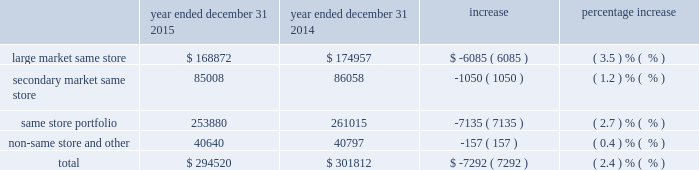The increase in property operating expenses from our large market same store group is primarily the result of increases in real estate taxes of $ 3.2 million , personnel expenses of $ 1.9 million , water expenses of approximately $ 1.0 million , cable expenses of $ 0.5 million , and waste removal expenses of $ 0.2 million .
The increase in property operating expenses from our secondary market same store group is primarily a result of increases in other operating expenses of $ 1.5 million , real estate taxes of $ 1.1 million , and personnel expenses of $ 1.2 million .
The decrease in property operating expenses from our non-same store and other group is primarily the result of decreases in personnel expenses of $ 2.4 million and utility expenses of $ 1.7 million .
Depreciation and amortization the table shows our depreciation and amortization expense by segment for the years ended december 31 , 2015 and december 31 , 2014 ( dollars in thousands ) : year ended december 31 , 2015 year ended december 31 , 2014 increase percentage increase .
The decrease in depreciation and amortization expense is primarily due to a decrease of $ 19.4 million related to the amortization of the fair value of in-place leases and resident relationships acquired as a result of the merger from the year ended december 31 , 2014 to the year ended december 31 , 2015 .
This decrease was partially offset by an increase in depreciation expense of $ 11.7 million driven by an increase in gross real estate assets from the year ended december 31 , 2014 to the year ended december 31 , 2015 .
Property management expenses property management expenses for the year ended december 31 , 2015 were approximately $ 31.0 million , a decrease of $ 1.1 million from the year ended december 31 , 2014 .
The majority of the decrease was related to a decrease in state franchise taxes of $ 2.1 million , partially offset by an increase in insurance expense of $ 0.6 million , an increase in payroll expense of $ 0.3 million , and an increase in incentive expense $ 0.3 million .
General and administrative expenses general and administrative expenses for the year ended december 31 , 2015 were approximately $ 25.7 million , an increase of $ 4.8 million from the year ended december 31 , 2014 .
The majority of the increase was related to increases in legal fees of $ 2.7 million and stock option expenses of $ 1.6 million .
Merger and integration related expenses there were no merger or integration related expenses for the year ended december 31 , 2015 , as these expenses related primarily to severance , legal , professional , temporary systems , staffing , and facilities costs incurred for the acquisition and integration of colonial .
For the year ended december 31 , 2014 , merger and integration related expenses were approximately $ 3.2 million and $ 8.4 million , respectively .
Interest expense interest expense for the year ended december 31 , 2015 was approximately $ 122.3 million , a decrease of $ 1.6 million from the year ended december 31 , 2014 .
The decrease was primarily the result of a decrease in amortization of deferred financing cost from the year ended december 31 , 2014 to the year ended december 31 , 2015 of approximately $ 0.9 million .
Also , the overall debt balance decreased from $ 3.5 billion to $ 3.4 billion , a decrease of $ 85.1 million .
The average effective interest rate remained at 3.7% ( 3.7 % ) and the average years to rate maturity increased from 4.4 years to 4.8 years .
Job title mid-america apartment 10-k revision 1 serial <12345678> date sunday , march 20 , 2016 job number 304352-1 type page no .
50 operator abigaels .
What is the variation observed in the percentual decrease of the large market same-store and the secondary market same-store during 2014 and 2015? 
Rationale: it is the difference between those percentages .
Computations: (3.5 - 1.2)
Answer: 2.3. The increase in property operating expenses from our large market same store group is primarily the result of increases in real estate taxes of $ 3.2 million , personnel expenses of $ 1.9 million , water expenses of approximately $ 1.0 million , cable expenses of $ 0.5 million , and waste removal expenses of $ 0.2 million .
The increase in property operating expenses from our secondary market same store group is primarily a result of increases in other operating expenses of $ 1.5 million , real estate taxes of $ 1.1 million , and personnel expenses of $ 1.2 million .
The decrease in property operating expenses from our non-same store and other group is primarily the result of decreases in personnel expenses of $ 2.4 million and utility expenses of $ 1.7 million .
Depreciation and amortization the table shows our depreciation and amortization expense by segment for the years ended december 31 , 2015 and december 31 , 2014 ( dollars in thousands ) : year ended december 31 , 2015 year ended december 31 , 2014 increase percentage increase .
The decrease in depreciation and amortization expense is primarily due to a decrease of $ 19.4 million related to the amortization of the fair value of in-place leases and resident relationships acquired as a result of the merger from the year ended december 31 , 2014 to the year ended december 31 , 2015 .
This decrease was partially offset by an increase in depreciation expense of $ 11.7 million driven by an increase in gross real estate assets from the year ended december 31 , 2014 to the year ended december 31 , 2015 .
Property management expenses property management expenses for the year ended december 31 , 2015 were approximately $ 31.0 million , a decrease of $ 1.1 million from the year ended december 31 , 2014 .
The majority of the decrease was related to a decrease in state franchise taxes of $ 2.1 million , partially offset by an increase in insurance expense of $ 0.6 million , an increase in payroll expense of $ 0.3 million , and an increase in incentive expense $ 0.3 million .
General and administrative expenses general and administrative expenses for the year ended december 31 , 2015 were approximately $ 25.7 million , an increase of $ 4.8 million from the year ended december 31 , 2014 .
The majority of the increase was related to increases in legal fees of $ 2.7 million and stock option expenses of $ 1.6 million .
Merger and integration related expenses there were no merger or integration related expenses for the year ended december 31 , 2015 , as these expenses related primarily to severance , legal , professional , temporary systems , staffing , and facilities costs incurred for the acquisition and integration of colonial .
For the year ended december 31 , 2014 , merger and integration related expenses were approximately $ 3.2 million and $ 8.4 million , respectively .
Interest expense interest expense for the year ended december 31 , 2015 was approximately $ 122.3 million , a decrease of $ 1.6 million from the year ended december 31 , 2014 .
The decrease was primarily the result of a decrease in amortization of deferred financing cost from the year ended december 31 , 2014 to the year ended december 31 , 2015 of approximately $ 0.9 million .
Also , the overall debt balance decreased from $ 3.5 billion to $ 3.4 billion , a decrease of $ 85.1 million .
The average effective interest rate remained at 3.7% ( 3.7 % ) and the average years to rate maturity increased from 4.4 years to 4.8 years .
Job title mid-america apartment 10-k revision 1 serial <12345678> date sunday , march 20 , 2016 job number 304352-1 type page no .
50 operator abigaels .
For the year ended december 31 2015 what was the ratio of the depreciation and amortization in the large market same store to the secondary market same store? 
Rationale: the ratio of the depreciation and amortization in the large market same store to the secondary market same store was 1.99 to in 2015
Computations: (168872 / 85008)
Answer: 1.98654. The increase in property operating expenses from our large market same store group is primarily the result of increases in real estate taxes of $ 3.2 million , personnel expenses of $ 1.9 million , water expenses of approximately $ 1.0 million , cable expenses of $ 0.5 million , and waste removal expenses of $ 0.2 million .
The increase in property operating expenses from our secondary market same store group is primarily a result of increases in other operating expenses of $ 1.5 million , real estate taxes of $ 1.1 million , and personnel expenses of $ 1.2 million .
The decrease in property operating expenses from our non-same store and other group is primarily the result of decreases in personnel expenses of $ 2.4 million and utility expenses of $ 1.7 million .
Depreciation and amortization the table shows our depreciation and amortization expense by segment for the years ended december 31 , 2015 and december 31 , 2014 ( dollars in thousands ) : year ended december 31 , 2015 year ended december 31 , 2014 increase percentage increase .
The decrease in depreciation and amortization expense is primarily due to a decrease of $ 19.4 million related to the amortization of the fair value of in-place leases and resident relationships acquired as a result of the merger from the year ended december 31 , 2014 to the year ended december 31 , 2015 .
This decrease was partially offset by an increase in depreciation expense of $ 11.7 million driven by an increase in gross real estate assets from the year ended december 31 , 2014 to the year ended december 31 , 2015 .
Property management expenses property management expenses for the year ended december 31 , 2015 were approximately $ 31.0 million , a decrease of $ 1.1 million from the year ended december 31 , 2014 .
The majority of the decrease was related to a decrease in state franchise taxes of $ 2.1 million , partially offset by an increase in insurance expense of $ 0.6 million , an increase in payroll expense of $ 0.3 million , and an increase in incentive expense $ 0.3 million .
General and administrative expenses general and administrative expenses for the year ended december 31 , 2015 were approximately $ 25.7 million , an increase of $ 4.8 million from the year ended december 31 , 2014 .
The majority of the increase was related to increases in legal fees of $ 2.7 million and stock option expenses of $ 1.6 million .
Merger and integration related expenses there were no merger or integration related expenses for the year ended december 31 , 2015 , as these expenses related primarily to severance , legal , professional , temporary systems , staffing , and facilities costs incurred for the acquisition and integration of colonial .
For the year ended december 31 , 2014 , merger and integration related expenses were approximately $ 3.2 million and $ 8.4 million , respectively .
Interest expense interest expense for the year ended december 31 , 2015 was approximately $ 122.3 million , a decrease of $ 1.6 million from the year ended december 31 , 2014 .
The decrease was primarily the result of a decrease in amortization of deferred financing cost from the year ended december 31 , 2014 to the year ended december 31 , 2015 of approximately $ 0.9 million .
Also , the overall debt balance decreased from $ 3.5 billion to $ 3.4 billion , a decrease of $ 85.1 million .
The average effective interest rate remained at 3.7% ( 3.7 % ) and the average years to rate maturity increased from 4.4 years to 4.8 years .
Job title mid-america apartment 10-k revision 1 serial <12345678> date sunday , march 20 , 2016 job number 304352-1 type page no .
50 operator abigaels .
Considering the year 2015 , what is the impact of the large market among the same store portfolio? 
Rationale: it is the value of the large market same-store divided by the total same-store portfolio , then turned into a percentage to represent the impact .
Computations: (168872 / 253880)
Answer: 0.66516. 